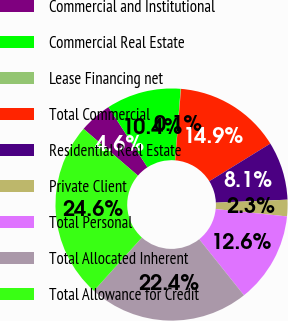<chart> <loc_0><loc_0><loc_500><loc_500><pie_chart><fcel>Commercial and Institutional<fcel>Commercial Real Estate<fcel>Lease Financing net<fcel>Total Commercial<fcel>Residential Real Estate<fcel>Private Client<fcel>Total Personal<fcel>Total Allocated Inherent<fcel>Total Allowance for Credit<nl><fcel>4.56%<fcel>10.39%<fcel>0.05%<fcel>14.9%<fcel>8.13%<fcel>2.3%<fcel>12.65%<fcel>22.38%<fcel>24.64%<nl></chart> 